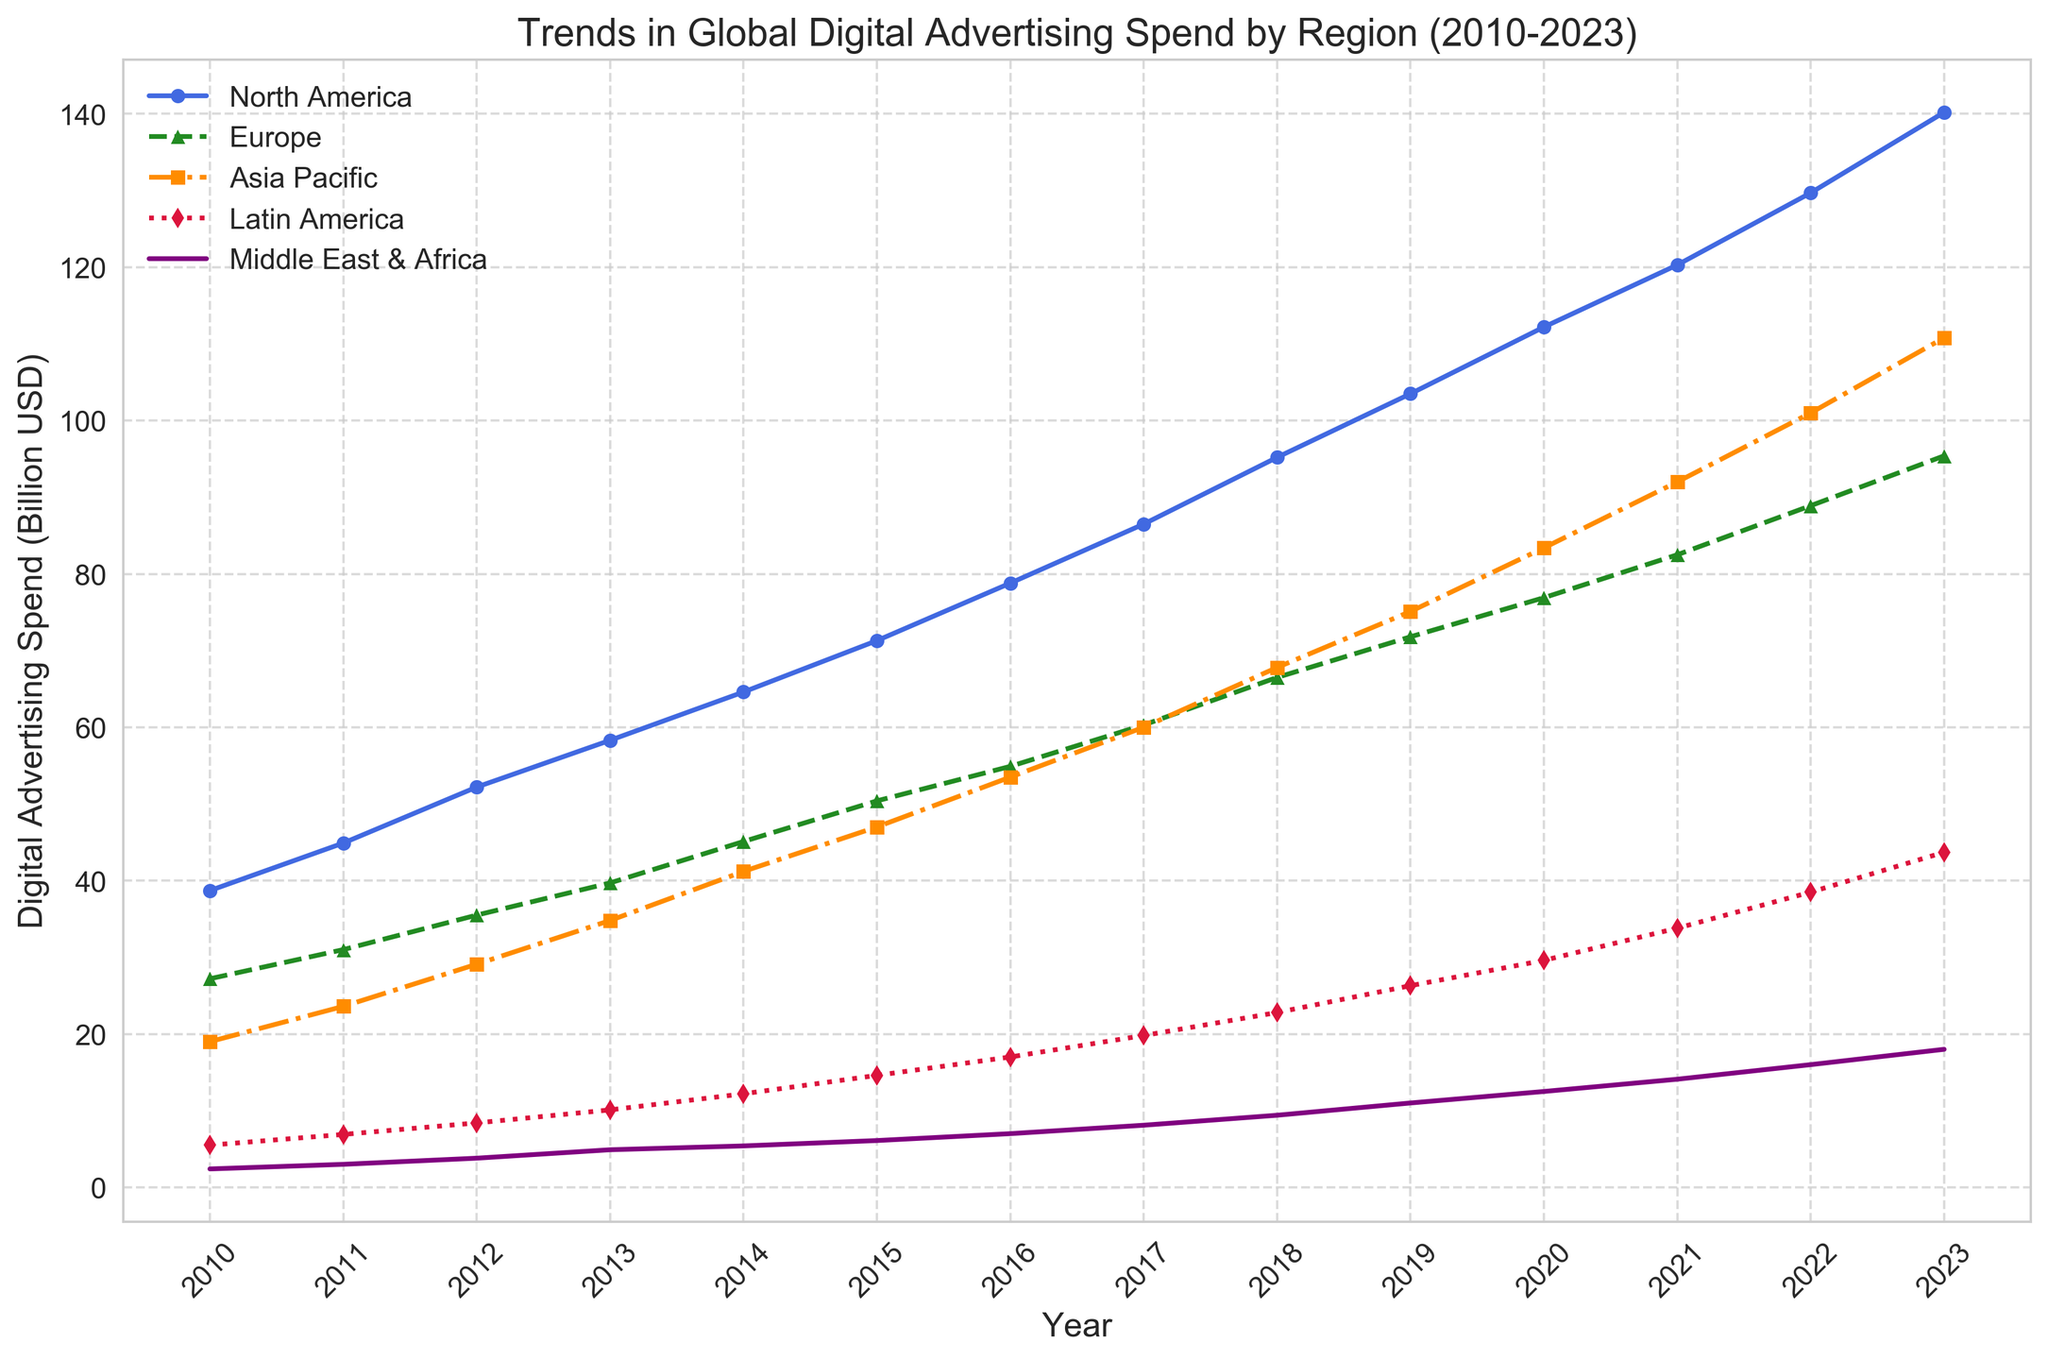What is the trend of digital advertising spend in North America from 2010 to 2023? The line graph displays the digital advertising spend across various regions over the years. For North America, the data shows a consistent and significant increase in spending, starting at 38.7 billion USD in 2010 and reaching 140.2 billion USD by 2023.
Answer: Consistently increasing Which region has the highest digital advertising spend in 2023? Comparing all the regions for the year 2023, North America shows the highest digital advertising spend at 140.2 billion USD.
Answer: North America What is the difference in digital advertising spend between Asia Pacific and Europe in 2022? In 2022, the digital advertising spend for Asia Pacific is 101.0 billion USD and for Europe is 88.9 billion USD. The difference between them is 101.0 - 88.9 = 12.1 billion USD.
Answer: 12.1 billion USD How has the digital advertising spend in Latin America changed from 2010 to 2023? The chart indicates an upward trend for Latin America. In 2010, the spend was 5.5 billion USD, and by 2023, it rose to 43.7 billion USD, marking a substantial increase over the period.
Answer: Increased significantly Which two regions have the closest digital advertising spend in 2020? Examining the 2020 values: North America (112.2), Europe (76.9), Asia Pacific (83.4), Latin America (29.6), Middle East & Africa (12.5). The closest spending values are Europe and Asia Pacific, with a difference of 6.5 billion USD.
Answer: Europe and Asia Pacific What is the total digital advertising spend in 2015 for all regions combined? Add up the spends for all regions in 2015: North America (71.3) + Europe (50.4) + Asia Pacific (47.0) + Latin America (14.6) + Middle East & Africa (6.1) = 189.4 billion USD.
Answer: 189.4 billion USD By how much did the digital advertising spend in the Middle East & Africa grow from 2010 to 2023? In 2010, the spend was 2.4 billion USD, and in 2023 it grew to 18.0 billion USD. The growth is calculated as 18.0 - 2.4 = 15.6 billion USD.
Answer: 15.6 billion USD Which region experienced the highest growth rate in digital advertising spend from 2010 to 2023? Observing the increases, we see: North America (101.5 billion USD), Europe (68.2 billion USD), Asia Pacific (91.8 billion USD), Latin America (38.2 billion USD), Middle East & Africa (15.6 billion USD). Asia Pacific shows the highest growth rate as its spending increased from 19.0 to 110.8 billion USD.
Answer: Asia Pacific 